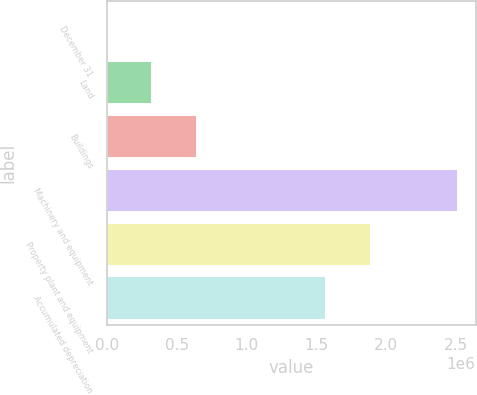Convert chart. <chart><loc_0><loc_0><loc_500><loc_500><bar_chart><fcel>December 31<fcel>Land<fcel>Buildings<fcel>Machinery and equipment<fcel>Property plant and equipment<fcel>Accumulated depreciation<nl><fcel>2003<fcel>324505<fcel>647007<fcel>2.51492e+06<fcel>1.88759e+06<fcel>1.56508e+06<nl></chart> 